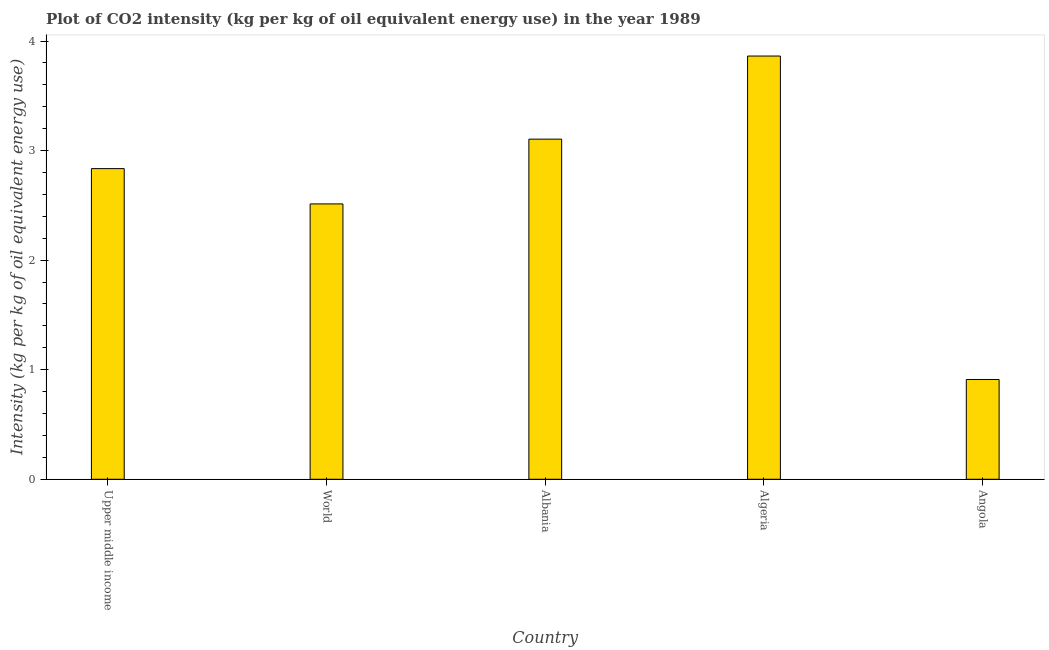Does the graph contain any zero values?
Your answer should be compact. No. What is the title of the graph?
Ensure brevity in your answer.  Plot of CO2 intensity (kg per kg of oil equivalent energy use) in the year 1989. What is the label or title of the X-axis?
Make the answer very short. Country. What is the label or title of the Y-axis?
Offer a very short reply. Intensity (kg per kg of oil equivalent energy use). What is the co2 intensity in Angola?
Your answer should be compact. 0.91. Across all countries, what is the maximum co2 intensity?
Offer a very short reply. 3.86. Across all countries, what is the minimum co2 intensity?
Offer a terse response. 0.91. In which country was the co2 intensity maximum?
Keep it short and to the point. Algeria. In which country was the co2 intensity minimum?
Provide a succinct answer. Angola. What is the sum of the co2 intensity?
Make the answer very short. 13.23. What is the difference between the co2 intensity in Albania and Angola?
Offer a very short reply. 2.19. What is the average co2 intensity per country?
Ensure brevity in your answer.  2.65. What is the median co2 intensity?
Provide a short and direct response. 2.84. In how many countries, is the co2 intensity greater than 1.4 kg?
Give a very brief answer. 4. What is the ratio of the co2 intensity in Albania to that in Upper middle income?
Keep it short and to the point. 1.09. Is the co2 intensity in Upper middle income less than that in World?
Provide a short and direct response. No. What is the difference between the highest and the second highest co2 intensity?
Make the answer very short. 0.76. What is the difference between the highest and the lowest co2 intensity?
Provide a succinct answer. 2.95. In how many countries, is the co2 intensity greater than the average co2 intensity taken over all countries?
Offer a very short reply. 3. How many bars are there?
Provide a succinct answer. 5. How many countries are there in the graph?
Keep it short and to the point. 5. What is the Intensity (kg per kg of oil equivalent energy use) in Upper middle income?
Your answer should be compact. 2.84. What is the Intensity (kg per kg of oil equivalent energy use) in World?
Provide a succinct answer. 2.51. What is the Intensity (kg per kg of oil equivalent energy use) of Albania?
Give a very brief answer. 3.1. What is the Intensity (kg per kg of oil equivalent energy use) in Algeria?
Provide a short and direct response. 3.86. What is the Intensity (kg per kg of oil equivalent energy use) in Angola?
Provide a succinct answer. 0.91. What is the difference between the Intensity (kg per kg of oil equivalent energy use) in Upper middle income and World?
Keep it short and to the point. 0.32. What is the difference between the Intensity (kg per kg of oil equivalent energy use) in Upper middle income and Albania?
Give a very brief answer. -0.27. What is the difference between the Intensity (kg per kg of oil equivalent energy use) in Upper middle income and Algeria?
Ensure brevity in your answer.  -1.03. What is the difference between the Intensity (kg per kg of oil equivalent energy use) in Upper middle income and Angola?
Offer a terse response. 1.92. What is the difference between the Intensity (kg per kg of oil equivalent energy use) in World and Albania?
Keep it short and to the point. -0.59. What is the difference between the Intensity (kg per kg of oil equivalent energy use) in World and Algeria?
Your answer should be very brief. -1.35. What is the difference between the Intensity (kg per kg of oil equivalent energy use) in World and Angola?
Your response must be concise. 1.6. What is the difference between the Intensity (kg per kg of oil equivalent energy use) in Albania and Algeria?
Offer a very short reply. -0.76. What is the difference between the Intensity (kg per kg of oil equivalent energy use) in Albania and Angola?
Provide a succinct answer. 2.19. What is the difference between the Intensity (kg per kg of oil equivalent energy use) in Algeria and Angola?
Make the answer very short. 2.95. What is the ratio of the Intensity (kg per kg of oil equivalent energy use) in Upper middle income to that in World?
Your response must be concise. 1.13. What is the ratio of the Intensity (kg per kg of oil equivalent energy use) in Upper middle income to that in Algeria?
Your answer should be very brief. 0.73. What is the ratio of the Intensity (kg per kg of oil equivalent energy use) in Upper middle income to that in Angola?
Offer a terse response. 3.11. What is the ratio of the Intensity (kg per kg of oil equivalent energy use) in World to that in Albania?
Your response must be concise. 0.81. What is the ratio of the Intensity (kg per kg of oil equivalent energy use) in World to that in Algeria?
Offer a very short reply. 0.65. What is the ratio of the Intensity (kg per kg of oil equivalent energy use) in World to that in Angola?
Provide a succinct answer. 2.76. What is the ratio of the Intensity (kg per kg of oil equivalent energy use) in Albania to that in Algeria?
Ensure brevity in your answer.  0.8. What is the ratio of the Intensity (kg per kg of oil equivalent energy use) in Albania to that in Angola?
Provide a short and direct response. 3.41. What is the ratio of the Intensity (kg per kg of oil equivalent energy use) in Algeria to that in Angola?
Keep it short and to the point. 4.24. 